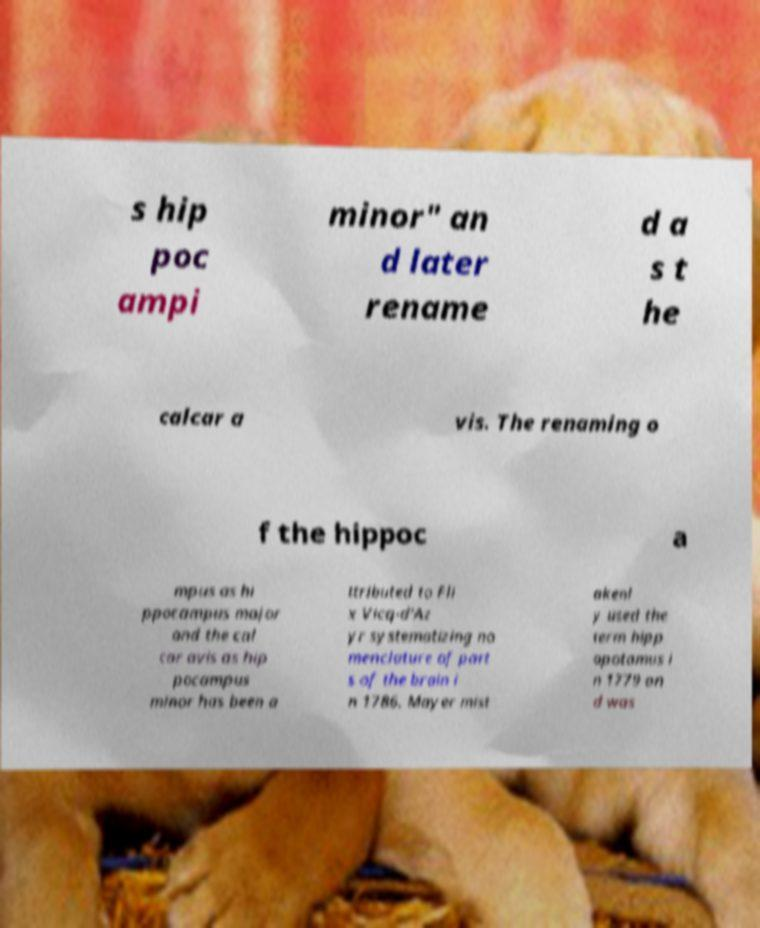Could you assist in decoding the text presented in this image and type it out clearly? s hip poc ampi minor" an d later rename d a s t he calcar a vis. The renaming o f the hippoc a mpus as hi ppocampus major and the cal car avis as hip pocampus minor has been a ttributed to Fli x Vicq-d'Az yr systematizing no menclature of part s of the brain i n 1786. Mayer mist akenl y used the term hipp opotamus i n 1779 an d was 